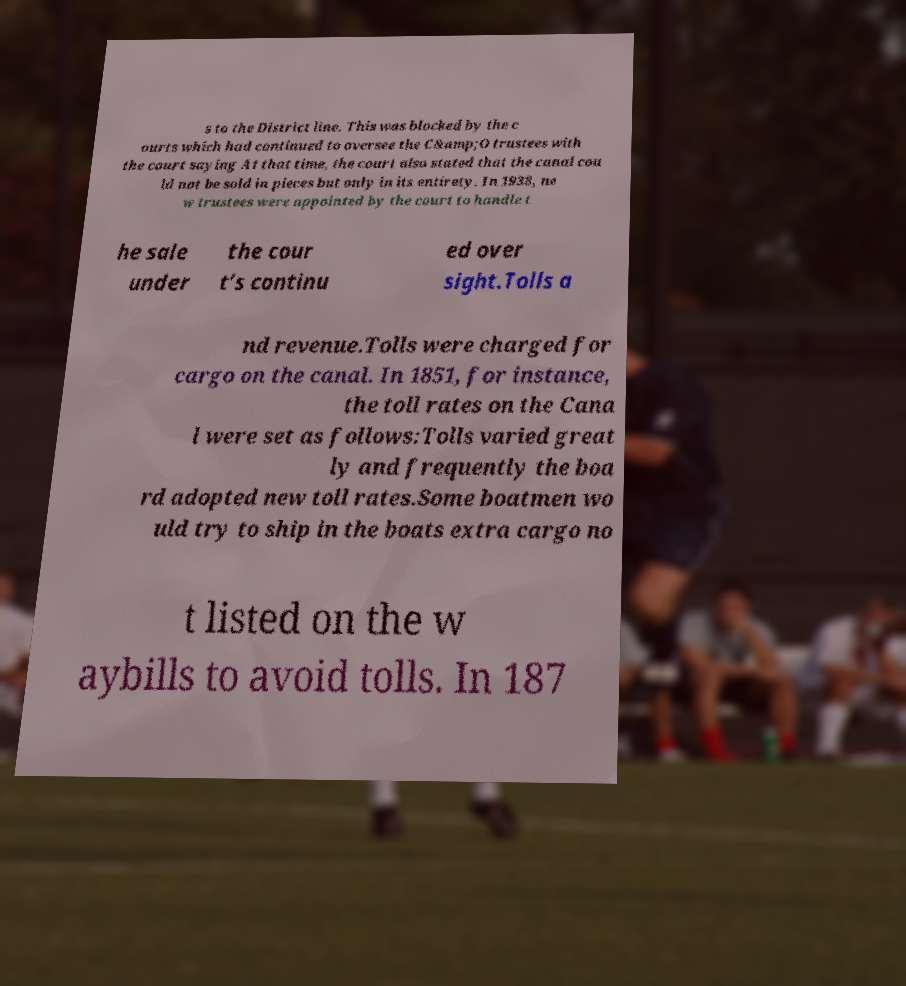Please read and relay the text visible in this image. What does it say? s to the District line. This was blocked by the c ourts which had continued to oversee the C&amp;O trustees with the court saying At that time, the court also stated that the canal cou ld not be sold in pieces but only in its entirety. In 1938, ne w trustees were appointed by the court to handle t he sale under the cour t’s continu ed over sight.Tolls a nd revenue.Tolls were charged for cargo on the canal. In 1851, for instance, the toll rates on the Cana l were set as follows:Tolls varied great ly and frequently the boa rd adopted new toll rates.Some boatmen wo uld try to ship in the boats extra cargo no t listed on the w aybills to avoid tolls. In 187 